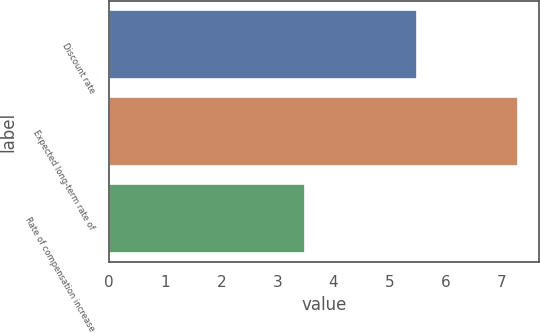Convert chart to OTSL. <chart><loc_0><loc_0><loc_500><loc_500><bar_chart><fcel>Discount rate<fcel>Expected long-term rate of<fcel>Rate of compensation increase<nl><fcel>5.5<fcel>7.3<fcel>3.5<nl></chart> 